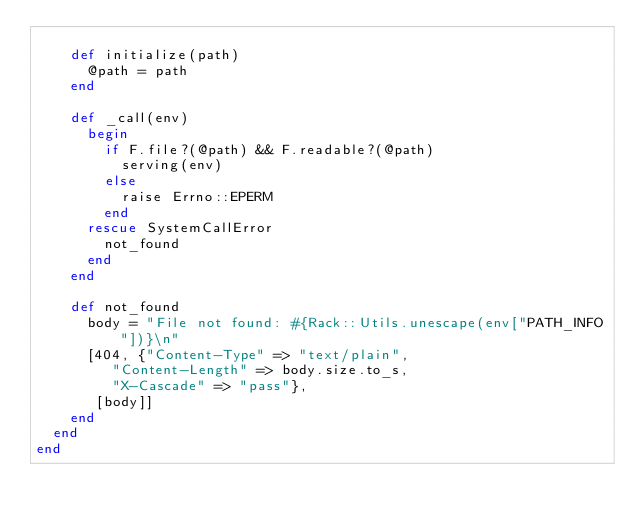<code> <loc_0><loc_0><loc_500><loc_500><_Ruby_>
    def initialize(path)
      @path = path
    end

    def _call(env)
      begin
        if F.file?(@path) && F.readable?(@path)
          serving(env)
        else
          raise Errno::EPERM
        end
      rescue SystemCallError
        not_found
      end
    end

    def not_found
      body = "File not found: #{Rack::Utils.unescape(env["PATH_INFO"])}\n"
      [404, {"Content-Type" => "text/plain",
         "Content-Length" => body.size.to_s,
         "X-Cascade" => "pass"},
       [body]]
    end
  end
end
</code> 